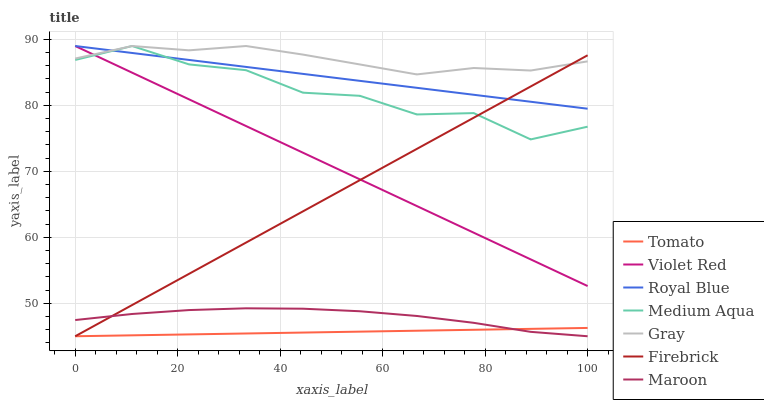Does Tomato have the minimum area under the curve?
Answer yes or no. Yes. Does Gray have the maximum area under the curve?
Answer yes or no. Yes. Does Violet Red have the minimum area under the curve?
Answer yes or no. No. Does Violet Red have the maximum area under the curve?
Answer yes or no. No. Is Firebrick the smoothest?
Answer yes or no. Yes. Is Medium Aqua the roughest?
Answer yes or no. Yes. Is Gray the smoothest?
Answer yes or no. No. Is Gray the roughest?
Answer yes or no. No. Does Tomato have the lowest value?
Answer yes or no. Yes. Does Violet Red have the lowest value?
Answer yes or no. No. Does Medium Aqua have the highest value?
Answer yes or no. Yes. Does Firebrick have the highest value?
Answer yes or no. No. Is Tomato less than Medium Aqua?
Answer yes or no. Yes. Is Gray greater than Tomato?
Answer yes or no. Yes. Does Royal Blue intersect Medium Aqua?
Answer yes or no. Yes. Is Royal Blue less than Medium Aqua?
Answer yes or no. No. Is Royal Blue greater than Medium Aqua?
Answer yes or no. No. Does Tomato intersect Medium Aqua?
Answer yes or no. No. 